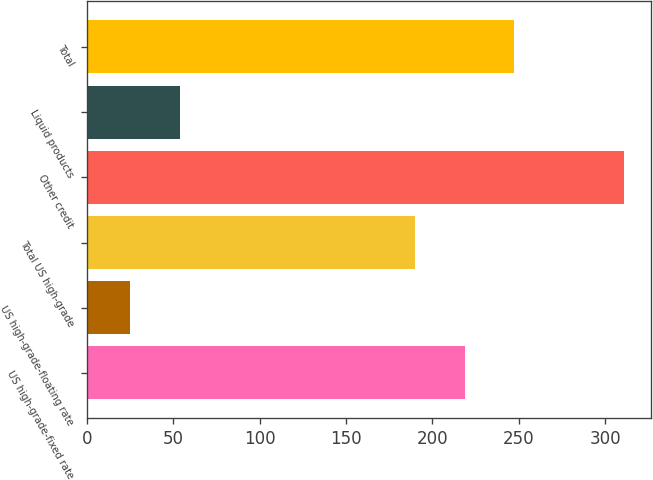Convert chart. <chart><loc_0><loc_0><loc_500><loc_500><bar_chart><fcel>US high-grade-fixed rate<fcel>US high-grade-floating rate<fcel>Total US high-grade<fcel>Other credit<fcel>Liquid products<fcel>Total<nl><fcel>218.6<fcel>25<fcel>190<fcel>311<fcel>53.6<fcel>247.2<nl></chart> 